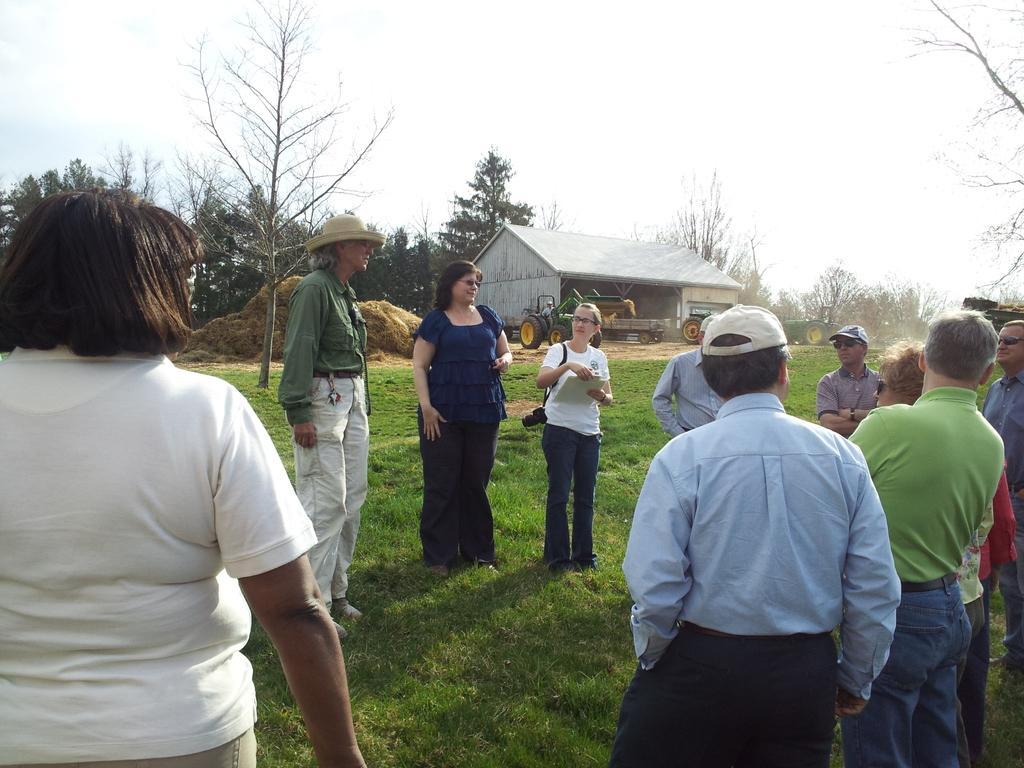In one or two sentences, can you explain what this image depicts? There are people standing and she is carrying a camera and holding an object,we can see grass. In the background we can see trees,dried grass,shed,vehicles,person and sky. 